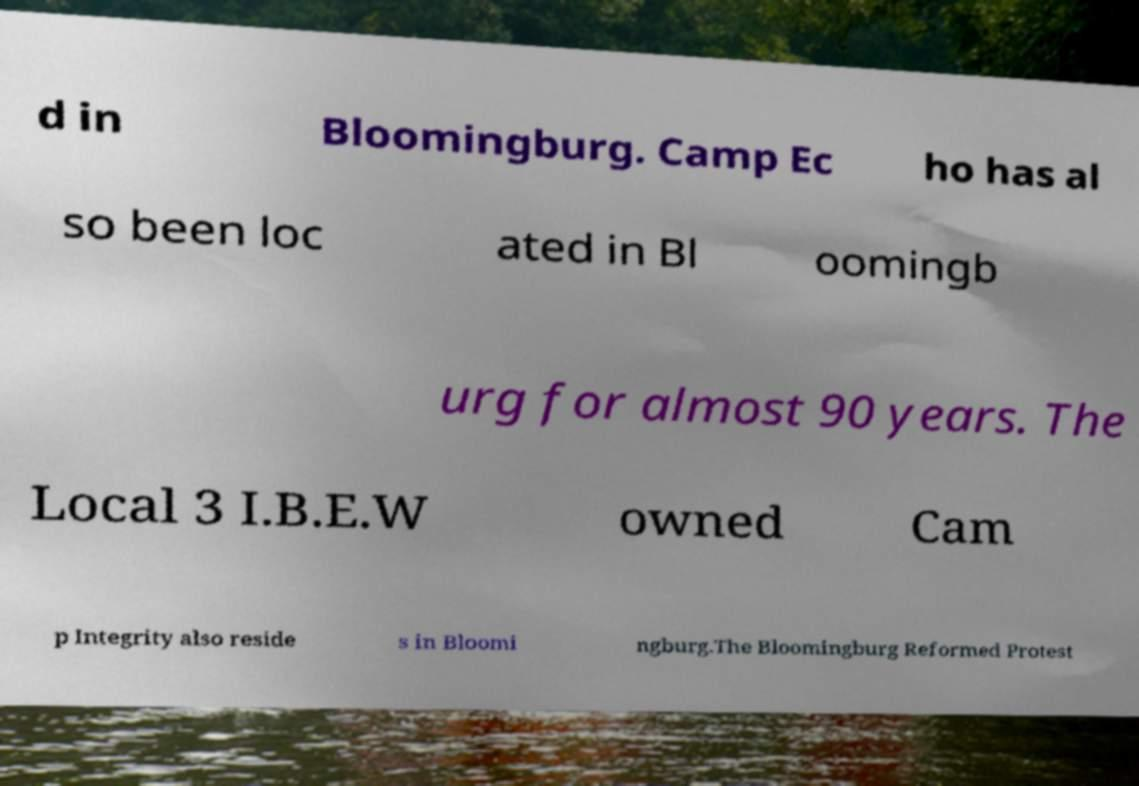I need the written content from this picture converted into text. Can you do that? d in Bloomingburg. Camp Ec ho has al so been loc ated in Bl oomingb urg for almost 90 years. The Local 3 I.B.E.W owned Cam p Integrity also reside s in Bloomi ngburg.The Bloomingburg Reformed Protest 